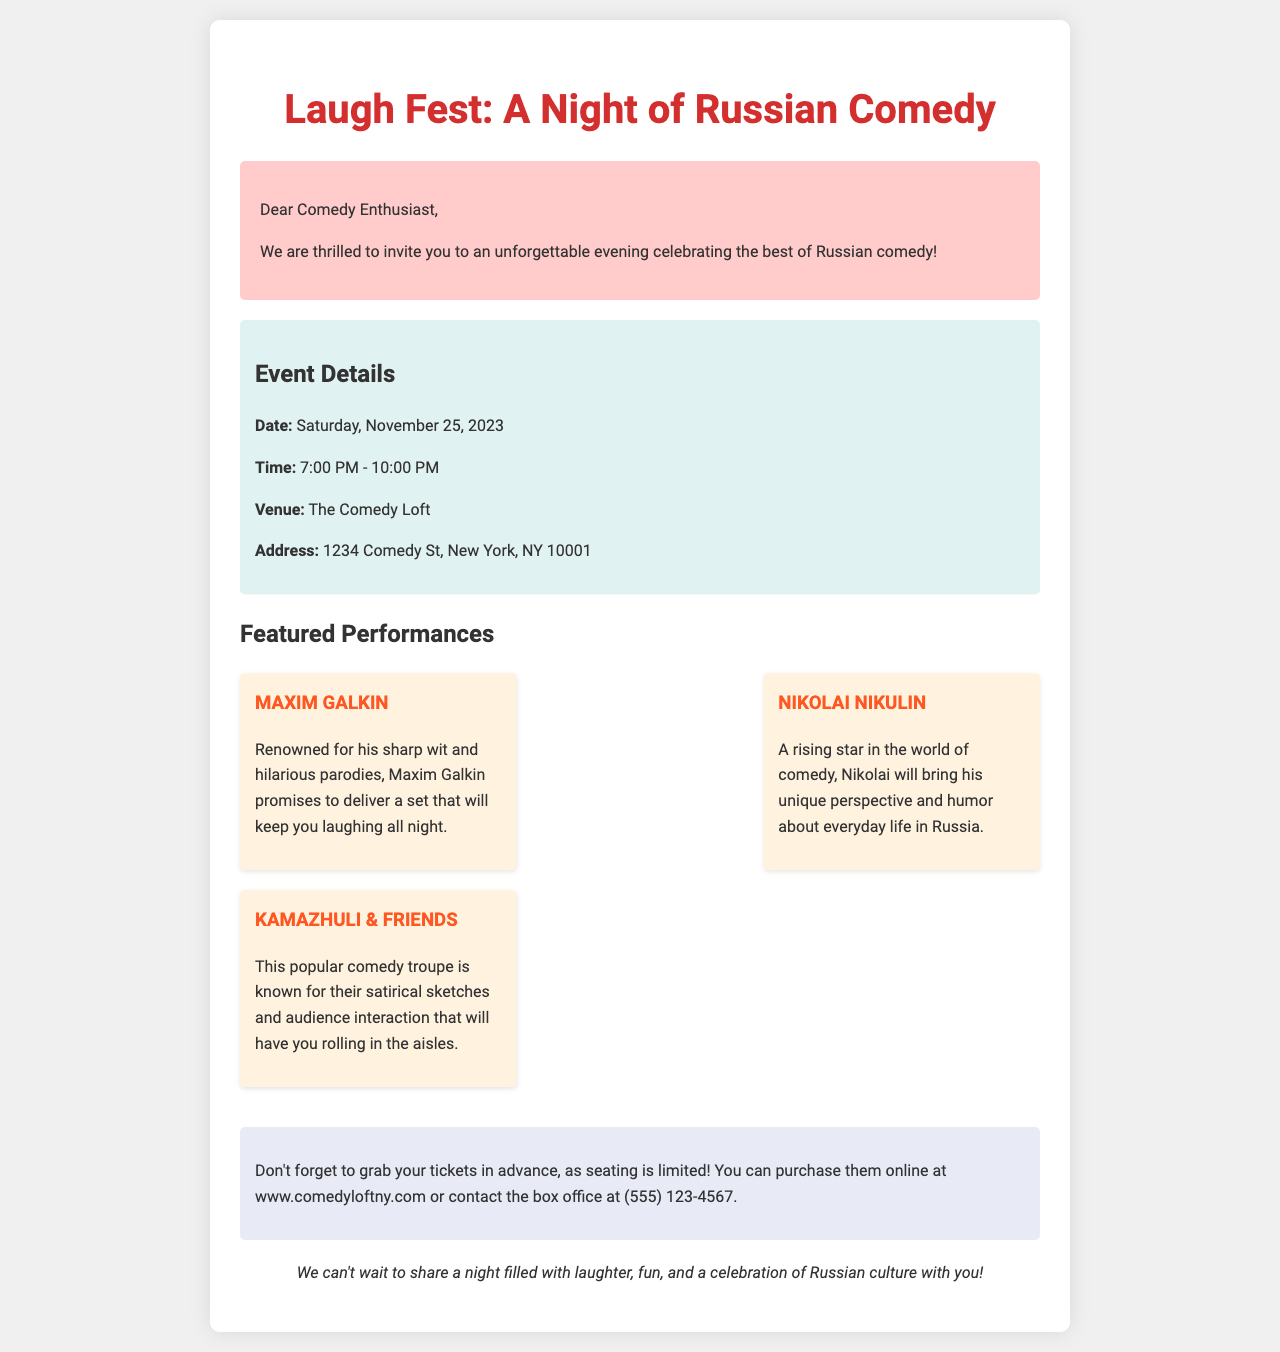what is the date of the event? The date of the event is explicitly mentioned in the document as Saturday, November 25, 2023.
Answer: Saturday, November 25, 2023 what time does the event start? The starting time for the event is provided in the document as 7:00 PM.
Answer: 7:00 PM where is the event taking place? The venue for the event is listed in the document as The Comedy Loft.
Answer: The Comedy Loft who is performing? The document lists several performers, including Maxim Galkin, Nikolai Nikulin, and Kamazhuli & Friends.
Answer: Maxim Galkin, Nikolai Nikulin, Kamazhuli & Friends why should I buy tickets in advance? The document states that seating is limited, thus emphasizing the need to purchase tickets in advance.
Answer: Seating is limited how can I purchase tickets? The document provides information on purchasing tickets online or through the box office by giving the website and contact number.
Answer: www.comedyloftny.com or (555) 123-4567 what type of comedy does Maxim Galkin perform? The document describes Maxim Galkin as renowned for his sharp wit and hilarious parodies, indicating the style of his comedy.
Answer: Sharp wit and hilarious parodies what kind of sketches do Kamazhuli & Friends perform? According to the document, Kamazhuli & Friends are known for their satirical sketches that include audience interaction.
Answer: Satirical sketches and audience interaction 